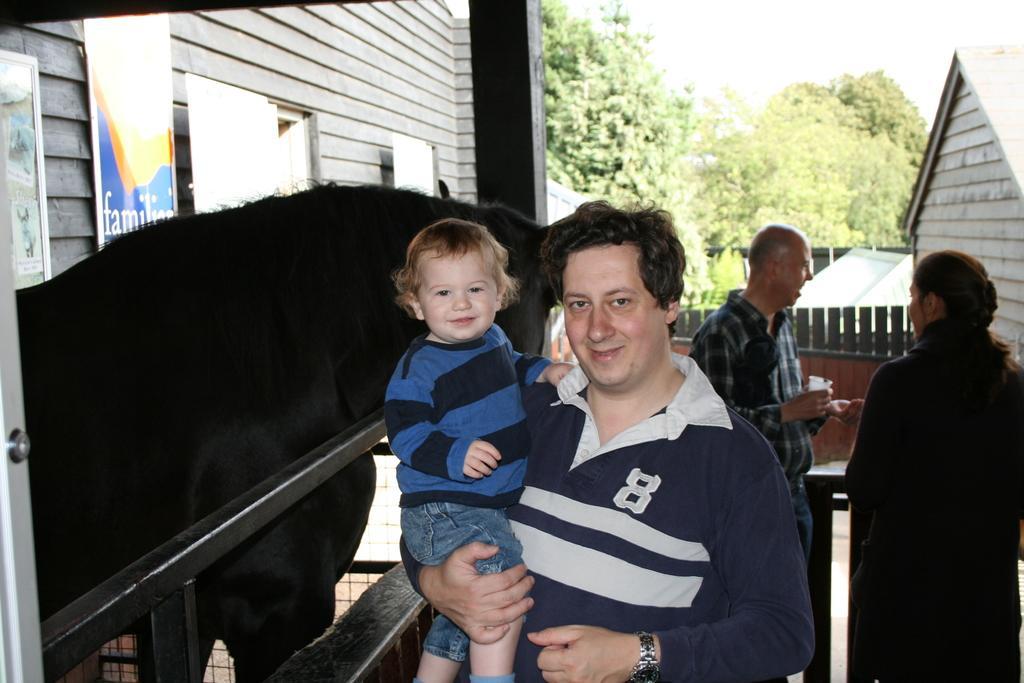Can you describe this image briefly? In this image I can see few people are standing and in the front I can see one man is holding a boy. On the both side of this image I can see few buildings and in the background I can see few trees. On the left side this image I can see few boards and on it I can see something is written. 